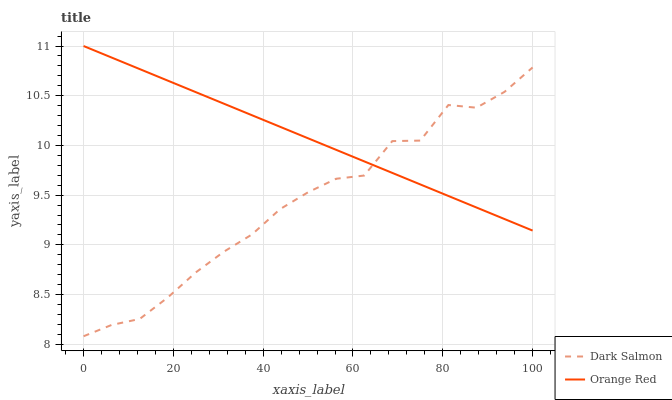Does Dark Salmon have the minimum area under the curve?
Answer yes or no. Yes. Does Orange Red have the maximum area under the curve?
Answer yes or no. Yes. Does Orange Red have the minimum area under the curve?
Answer yes or no. No. Is Orange Red the smoothest?
Answer yes or no. Yes. Is Dark Salmon the roughest?
Answer yes or no. Yes. Is Orange Red the roughest?
Answer yes or no. No. Does Dark Salmon have the lowest value?
Answer yes or no. Yes. Does Orange Red have the lowest value?
Answer yes or no. No. Does Orange Red have the highest value?
Answer yes or no. Yes. Does Dark Salmon intersect Orange Red?
Answer yes or no. Yes. Is Dark Salmon less than Orange Red?
Answer yes or no. No. Is Dark Salmon greater than Orange Red?
Answer yes or no. No. 